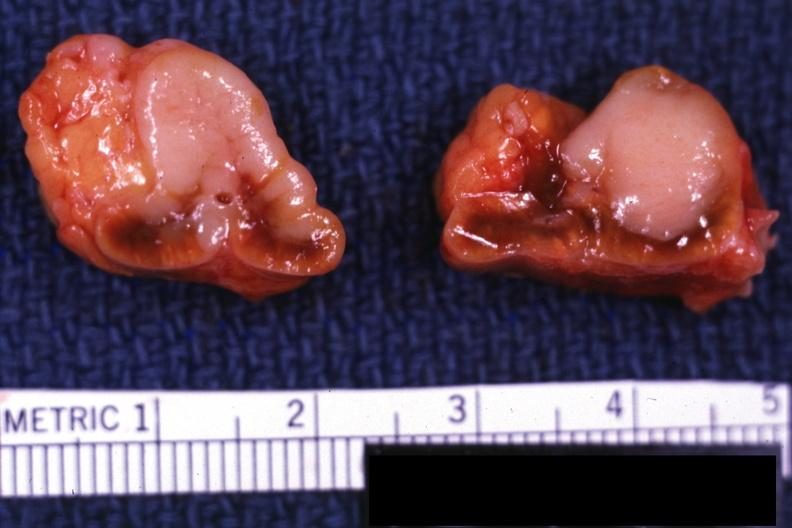s this section present?
Answer the question using a single word or phrase. No 